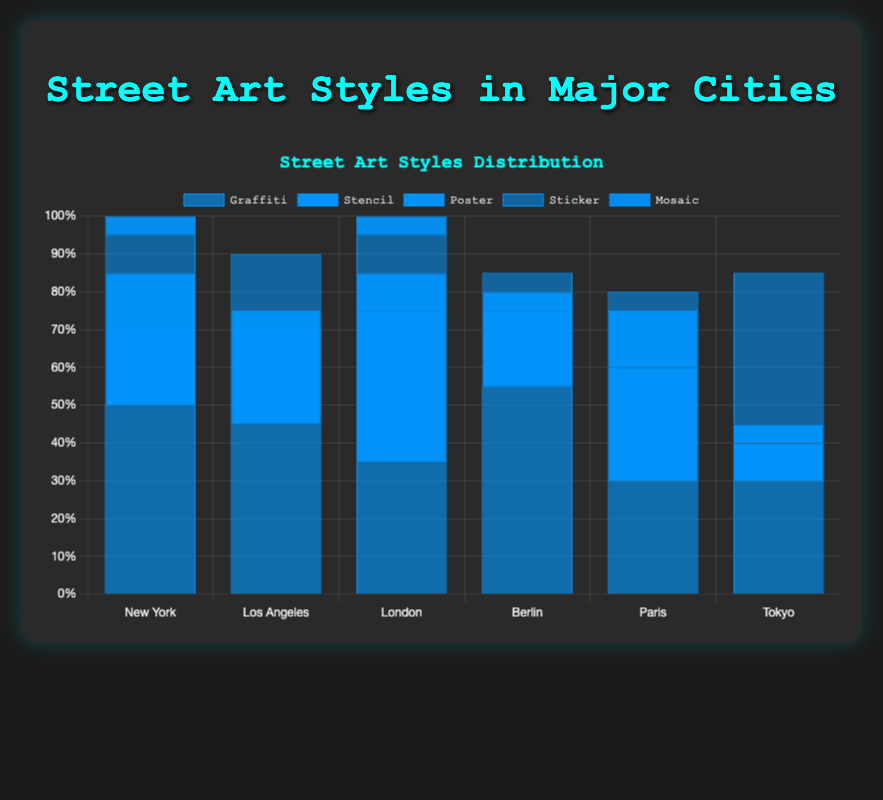What city has the highest percentage of Graffiti art? Look at the heights of the bars representing Graffiti in each city. Berlin has the tallest Graffiti bar, which means it has the highest percentage of Graffiti art.
Answer: Berlin Which style of street art is the most common in Tokyo? Check the heights of the bars corresponding to different styles of street art in Tokyo. The Sticker bar is the tallest, indicating that Sticker is the most common street art style in Tokyo.
Answer: Sticker What is the total percentage of Mural art in Los Angeles, Berlin, and Paris? Add the heights of the bars representing Mural art for Los Angeles, Berlin, and Paris: 10% (Los Angeles) + 15% (Berlin) + 20% (Paris).
Answer: 45% How does the popularity of Stencil art in London compare to New York? Compare the heights of the bars representing Stencil art in both London and New York. The Stencil bar for London is taller, indicating that Stencil art is more popular in London.
Answer: London is more popular Which city has the least amount of Poster street art? Look at the heights of the Poster bars in each city and identify the shortest one. Los Angeles and Berlin both have the shortest Poster bars at 5% each.
Answer: Los Angeles and Berlin Is the percentage of Mosaic art in New York greater than in London? Compare the heights of the Mosaic bars for New York and London. The Mosaic bar for both cities is the same height, at 5%.
Answer: No, they are equal What is the average percentage of Graffiti art across all cities? Add the percentages of Graffiti art in all cities and divide by the number of cities: (50 + 45 + 35 + 55 + 30 + 30) / 6. Sum is 245, and the average is 245/6.
Answer: 40.83 In which city is Sticker art the least common, and what is that percentage? Look at the heights of the Sticker bars in each city and find the shortest one. Paris and Berlin both have the lowest Sticker bar at 5%.
Answer: Paris and Berlin, 5% Among the cities listed, which one has an equal percentage of Stencil and Graffiti street art? Compare the bars for Stencil and Graffiti for each city. Only Paris has equal length bars for Stencil and Graffiti at 30%.
Answer: Paris What is the combined percentage of Poster and Sticker art in New York? Add the percentages for Poster and Sticker in New York: 15% (Poster) + 10% (Sticker).
Answer: 25% 